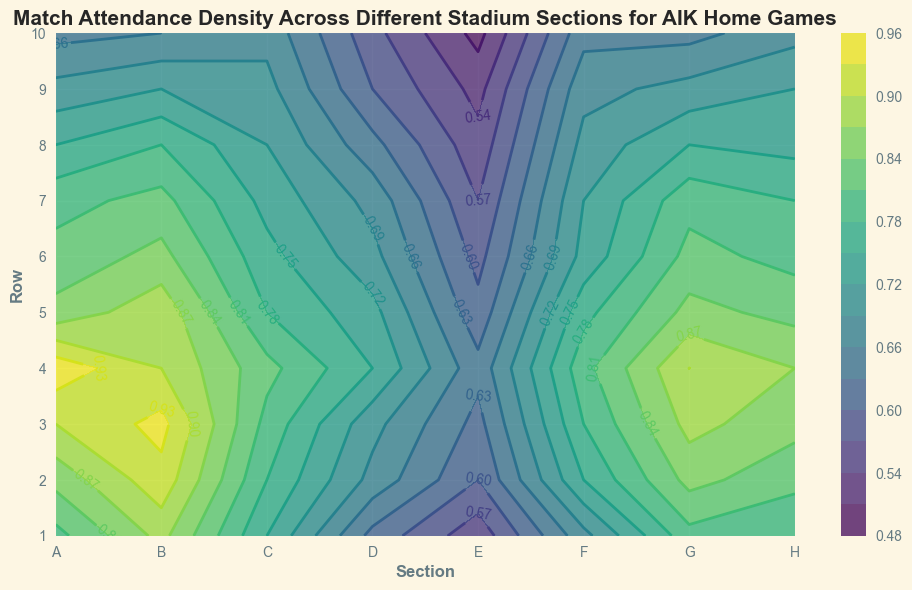What section has the highest match attendance density overall? By examining the contour lines and color intensity on the plot, Section B shows the darkest and most consistent high values across most rows, indicating the highest attendance density overall.
Answer: B Which section has the lowest match attendance density overall, and what is its range? By looking at the lightness of the color and the contour labels, Section E has the lowest attendance densities, ranging roughly from 0.50 to 0.64.
Answer: E, 0.50 - 0.64 What's the average attendance density for Row 3 across all sections? Calculate the average by summing the values of Row 3 for all sections and dividing by the number of sections. (0.90 + 0.94 + 0.80 + 0.70 + 0.62 + 0.78 + 0.88 + 0.85) / 8 = 6.47 / 8 ≈ 0.81.
Answer: 0.81 Between Sections A and C, which has a greater variance in attendance density across all rows? Calculate the variance by assessing the fluctuation from the highest to the lowest values in each section. Section A ranges from 0.95 to 0.65, and Section C ranges from 0.82 to 0.68. Section A has a wider range, indicating greater variance.
Answer: A Which sections show a decrease in attendance density from row 1 to row 10? Observing the contour labels from row 1 to row 10, all sections (A through H) show a general decreasing trend, but it is most evident in Sections D and E.
Answer: D, E What's the total attendance density sum for Section G? Sum the attendance densities for Section G across all rows: 0.80 + 0.85 + 0.88 + 0.90 + 0.85 + 0.82 + 0.80 + 0.75 + 0.70 + 0.65 = 7.00.
Answer: 7.00 Looking at the contour plot, which section has the closest median attendance density to 0.75? Identify the middle value for each section. Section C's values are close to 0.75, especially around rows 4 to 8.
Answer: C For Section H, what is the difference in attendance density between Row 1 and Row 10? Subtract the attendance density of Row 10 from Row 1 for Section H: 0.78 - 0.68 = 0.10.
Answer: 0.10 Compare the attendance density trends between Section F and Section B. What is the common trend? Both Section F and Section B show a high attendance density in the top rows (1-4) that gradually decreases towards the lower rows (5-10), indicating a similar trend.
Answer: High to Low What differentiates Sections with higher attendance density (like B and G) from lower density sections (like E) visually, in terms of contour lines and color intensity? Sections B and G have closer and more frequent contour lines with darker shading, indicating higher density, whereas Section E has fewer and more spread-out contour lines with lighter shading, indicating lower density.
Answer: Tighter/darker vs. Spread-out/lighter 